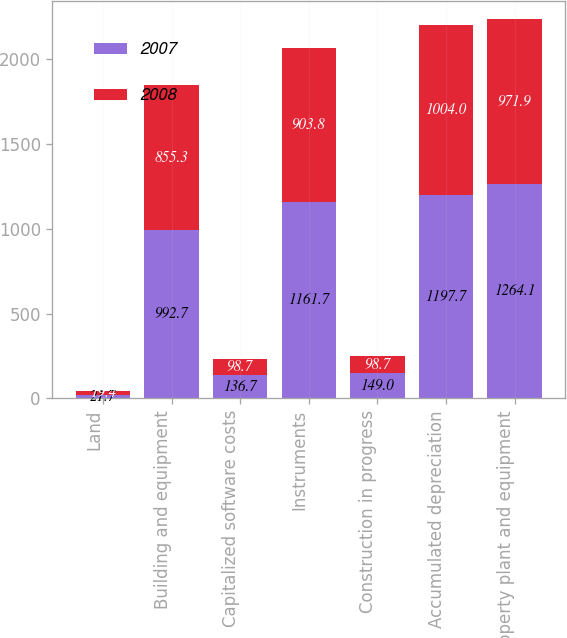Convert chart. <chart><loc_0><loc_0><loc_500><loc_500><stacked_bar_chart><ecel><fcel>Land<fcel>Building and equipment<fcel>Capitalized software costs<fcel>Instruments<fcel>Construction in progress<fcel>Accumulated depreciation<fcel>Property plant and equipment<nl><fcel>2007<fcel>21.7<fcel>992.7<fcel>136.7<fcel>1161.7<fcel>149<fcel>1197.7<fcel>1264.1<nl><fcel>2008<fcel>19.4<fcel>855.3<fcel>98.7<fcel>903.8<fcel>98.7<fcel>1004<fcel>971.9<nl></chart> 